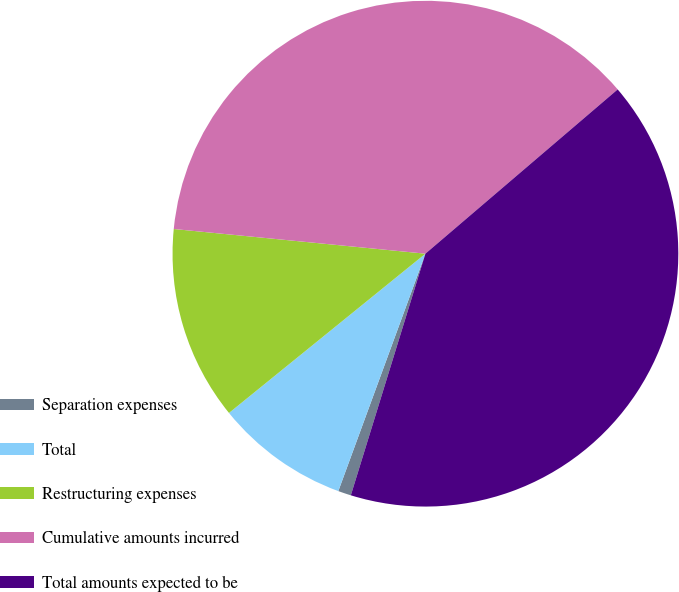Convert chart to OTSL. <chart><loc_0><loc_0><loc_500><loc_500><pie_chart><fcel>Separation expenses<fcel>Total<fcel>Restructuring expenses<fcel>Cumulative amounts incurred<fcel>Total amounts expected to be<nl><fcel>0.83%<fcel>8.56%<fcel>12.4%<fcel>37.19%<fcel>41.02%<nl></chart> 